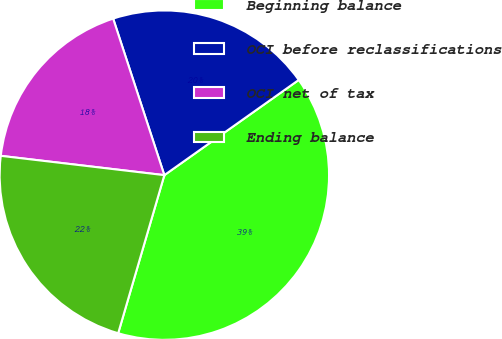<chart> <loc_0><loc_0><loc_500><loc_500><pie_chart><fcel>Beginning balance<fcel>OCI before reclassifications<fcel>OCI net of tax<fcel>Ending balance<nl><fcel>39.33%<fcel>20.22%<fcel>18.1%<fcel>22.35%<nl></chart> 